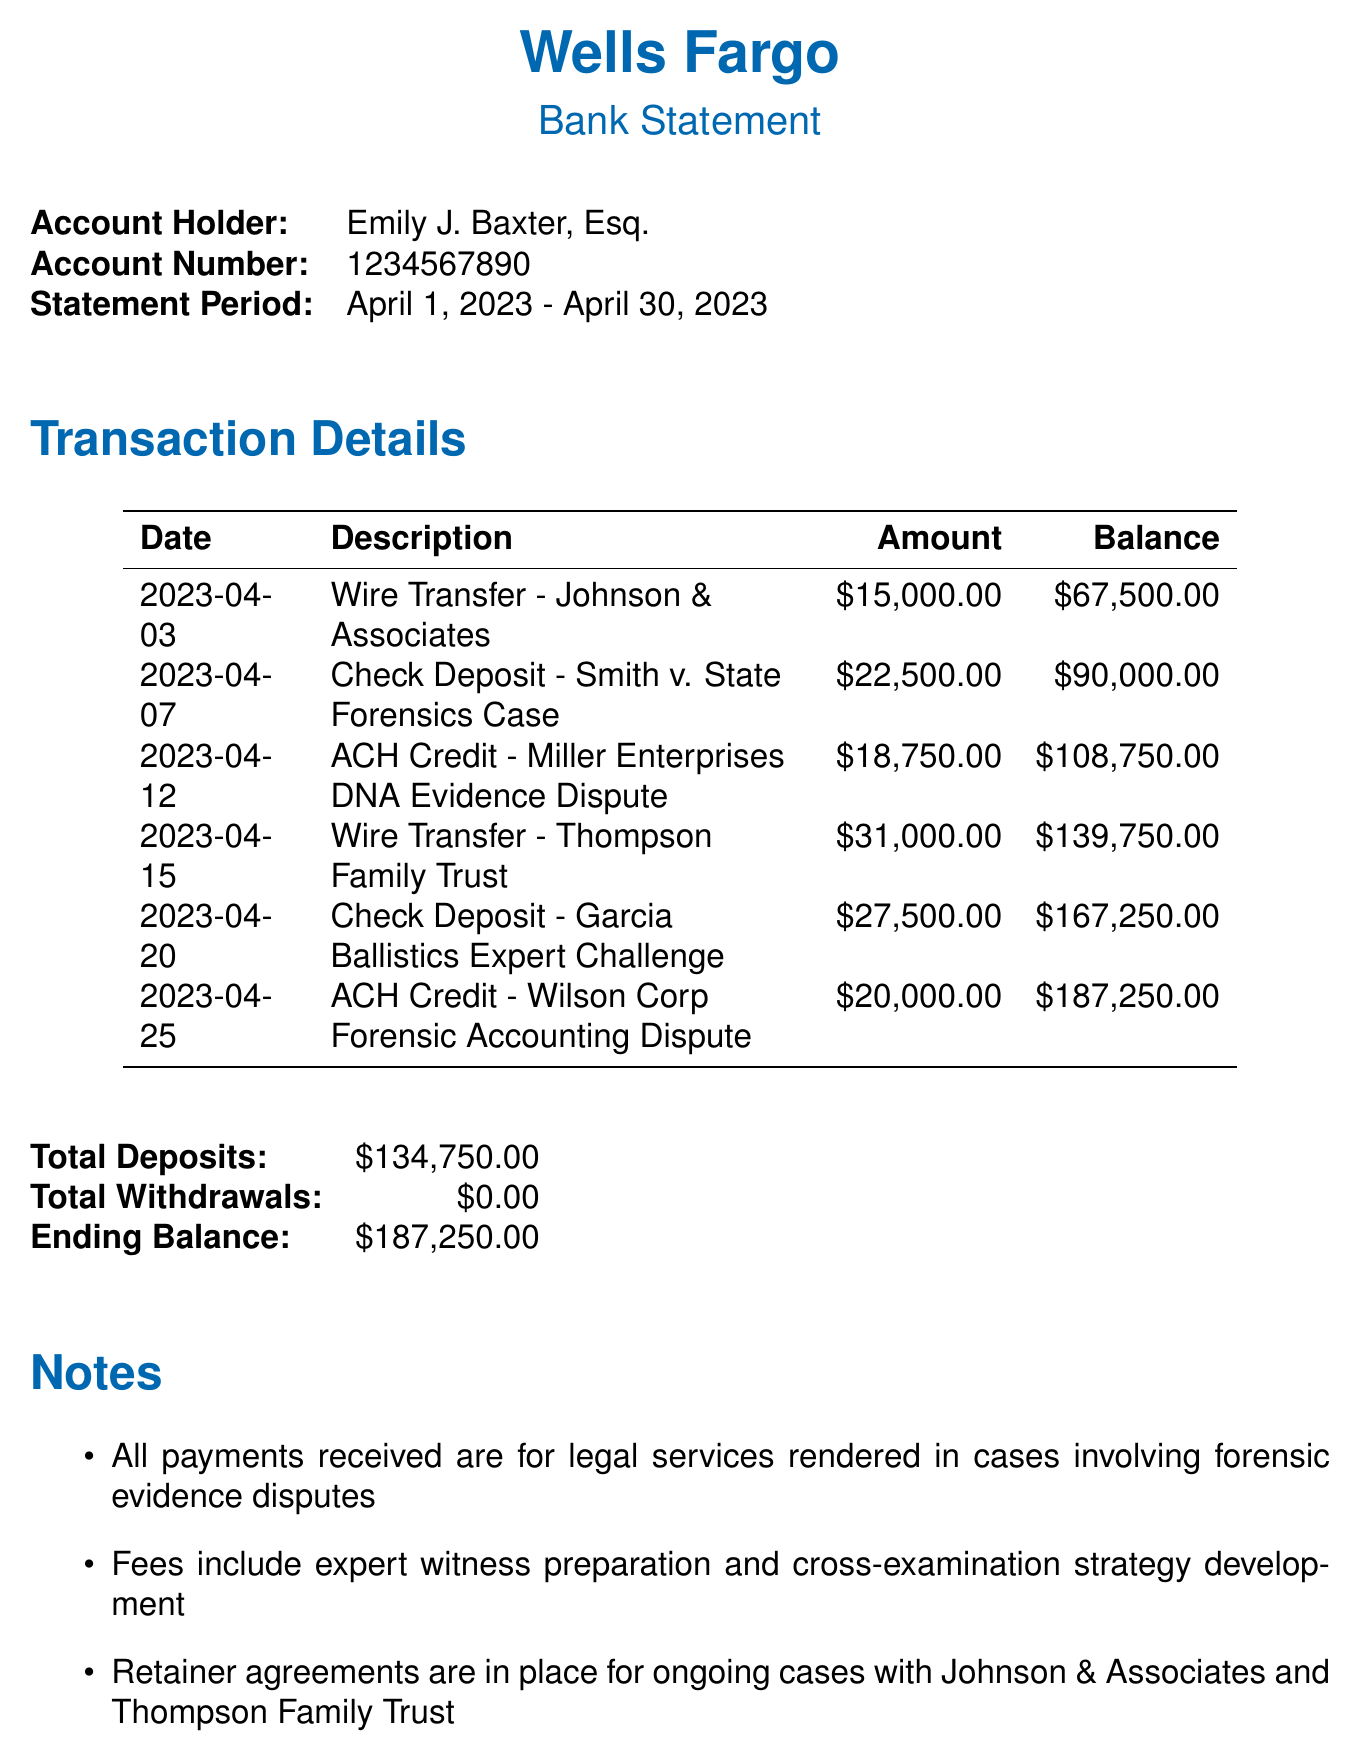what is the account holder's name? The account holder's name is specifically listed in the document, identifying Emily J. Baxter, Esq.
Answer: Emily J. Baxter, Esq what is the statement period covered? The statement period provides the dates for the transactions and is stated clearly in the document as from April 1, 2023, to April 30, 2023.
Answer: April 1, 2023 - April 30, 2023 how much was received from Johnson & Associates? The amount listed for the transaction related to Johnson & Associates is detailed as a wire transfer in the transaction list.
Answer: $15,000.00 what type of payment was made on April 12, 2023? The payment made on April 12, 2023, is mentioned in the transaction details as an ACH credit.
Answer: ACH Credit what is the ending balance of the account? The document provides a final summary with the total balance at the end of the statement period, indicating how much is left in the account.
Answer: $187,250.00 how many total deposits were made during the statement period? The total deposits can be calculated from the sum of all listed payment amounts in the transactions array of the document.
Answer: $134,750.00 what case is associated with the payment expected from Davis Incorporated? The document specifies upcoming payments along with their related case descriptions indicating what each payment is for.
Answer: Challenging DNA evidence collection methods how many payments are listed in the transactions? The number of transactions is found by counting each line item provided in the transaction details section of the document.
Answer: 6 what type of services are mentioned in the notes? The notes section outlines specific services provided by the law firm in relation to the forensic evidence.
Answer: Expert witness preparation and cross-examination strategy development 